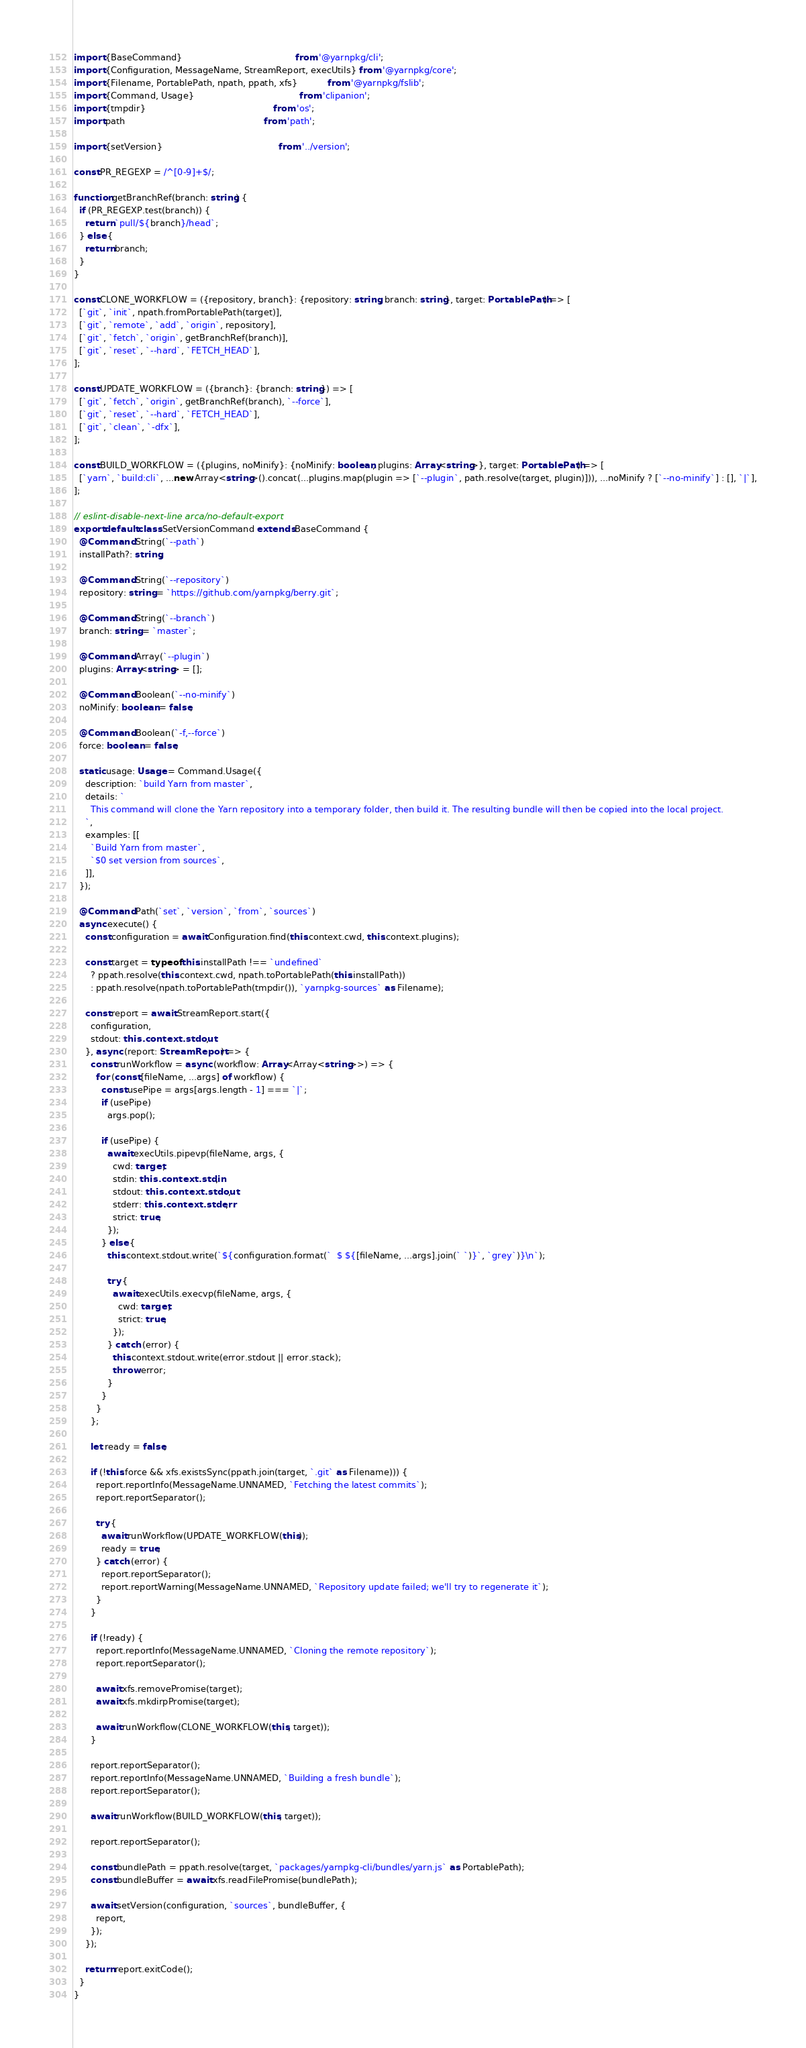<code> <loc_0><loc_0><loc_500><loc_500><_TypeScript_>import {BaseCommand}                                         from '@yarnpkg/cli';
import {Configuration, MessageName, StreamReport, execUtils} from '@yarnpkg/core';
import {Filename, PortablePath, npath, ppath, xfs}           from '@yarnpkg/fslib';
import {Command, Usage}                                      from 'clipanion';
import {tmpdir}                                              from 'os';
import path                                                  from 'path';

import {setVersion}                                          from '../version';

const PR_REGEXP = /^[0-9]+$/;

function getBranchRef(branch: string) {
  if (PR_REGEXP.test(branch)) {
    return `pull/${branch}/head`;
  } else {
    return branch;
  }
}

const CLONE_WORKFLOW = ({repository, branch}: {repository: string, branch: string}, target: PortablePath) => [
  [`git`, `init`, npath.fromPortablePath(target)],
  [`git`, `remote`, `add`, `origin`, repository],
  [`git`, `fetch`, `origin`, getBranchRef(branch)],
  [`git`, `reset`, `--hard`, `FETCH_HEAD`],
];

const UPDATE_WORKFLOW = ({branch}: {branch: string}) => [
  [`git`, `fetch`, `origin`, getBranchRef(branch), `--force`],
  [`git`, `reset`, `--hard`, `FETCH_HEAD`],
  [`git`, `clean`, `-dfx`],
];

const BUILD_WORKFLOW = ({plugins, noMinify}: {noMinify: boolean, plugins: Array<string>}, target: PortablePath) => [
  [`yarn`, `build:cli`, ...new Array<string>().concat(...plugins.map(plugin => [`--plugin`, path.resolve(target, plugin)])), ...noMinify ? [`--no-minify`] : [], `|`],
];

// eslint-disable-next-line arca/no-default-export
export default class SetVersionCommand extends BaseCommand {
  @Command.String(`--path`)
  installPath?: string;

  @Command.String(`--repository`)
  repository: string = `https://github.com/yarnpkg/berry.git`;

  @Command.String(`--branch`)
  branch: string = `master`;

  @Command.Array(`--plugin`)
  plugins: Array<string> = [];

  @Command.Boolean(`--no-minify`)
  noMinify: boolean = false;

  @Command.Boolean(`-f,--force`)
  force: boolean = false;

  static usage: Usage = Command.Usage({
    description: `build Yarn from master`,
    details: `
      This command will clone the Yarn repository into a temporary folder, then build it. The resulting bundle will then be copied into the local project.
    `,
    examples: [[
      `Build Yarn from master`,
      `$0 set version from sources`,
    ]],
  });

  @Command.Path(`set`, `version`, `from`, `sources`)
  async execute() {
    const configuration = await Configuration.find(this.context.cwd, this.context.plugins);

    const target = typeof this.installPath !== `undefined`
      ? ppath.resolve(this.context.cwd, npath.toPortablePath(this.installPath))
      : ppath.resolve(npath.toPortablePath(tmpdir()), `yarnpkg-sources` as Filename);

    const report = await StreamReport.start({
      configuration,
      stdout: this.context.stdout,
    }, async (report: StreamReport) => {
      const runWorkflow = async (workflow: Array<Array<string>>) => {
        for (const [fileName, ...args] of workflow) {
          const usePipe = args[args.length - 1] === `|`;
          if (usePipe)
            args.pop();

          if (usePipe) {
            await execUtils.pipevp(fileName, args, {
              cwd: target,
              stdin: this.context.stdin,
              stdout: this.context.stdout,
              stderr: this.context.stderr,
              strict: true,
            });
          } else {
            this.context.stdout.write(`${configuration.format(`  $ ${[fileName, ...args].join(` `)}`, `grey`)}\n`);

            try {
              await execUtils.execvp(fileName, args, {
                cwd: target,
                strict: true,
              });
            } catch (error) {
              this.context.stdout.write(error.stdout || error.stack);
              throw error;
            }
          }
        }
      };

      let ready = false;

      if (!this.force && xfs.existsSync(ppath.join(target, `.git` as Filename))) {
        report.reportInfo(MessageName.UNNAMED, `Fetching the latest commits`);
        report.reportSeparator();

        try {
          await runWorkflow(UPDATE_WORKFLOW(this));
          ready = true;
        } catch (error) {
          report.reportSeparator();
          report.reportWarning(MessageName.UNNAMED, `Repository update failed; we'll try to regenerate it`);
        }
      }

      if (!ready) {
        report.reportInfo(MessageName.UNNAMED, `Cloning the remote repository`);
        report.reportSeparator();

        await xfs.removePromise(target);
        await xfs.mkdirpPromise(target);

        await runWorkflow(CLONE_WORKFLOW(this, target));
      }

      report.reportSeparator();
      report.reportInfo(MessageName.UNNAMED, `Building a fresh bundle`);
      report.reportSeparator();

      await runWorkflow(BUILD_WORKFLOW(this, target));

      report.reportSeparator();

      const bundlePath = ppath.resolve(target, `packages/yarnpkg-cli/bundles/yarn.js` as PortablePath);
      const bundleBuffer = await xfs.readFilePromise(bundlePath);

      await setVersion(configuration, `sources`, bundleBuffer, {
        report,
      });
    });

    return report.exitCode();
  }
}
</code> 